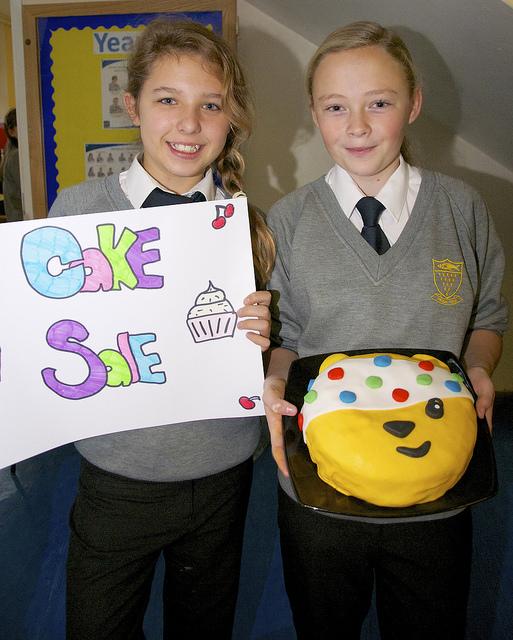What animal does the cake look like?
Short answer required. Bear. What color are the girl's sweaters?
Keep it brief. Gray. What does the sign that the girls is holding say?
Be succinct. Cake sale. 